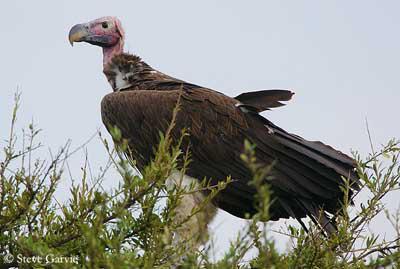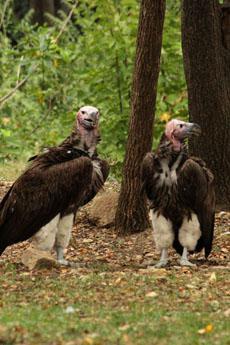The first image is the image on the left, the second image is the image on the right. Considering the images on both sides, is "Two birds are perched on a branch in the image on the right." valid? Answer yes or no. No. The first image is the image on the left, the second image is the image on the right. For the images displayed, is the sentence "An image contains no more than one vulture." factually correct? Answer yes or no. Yes. 